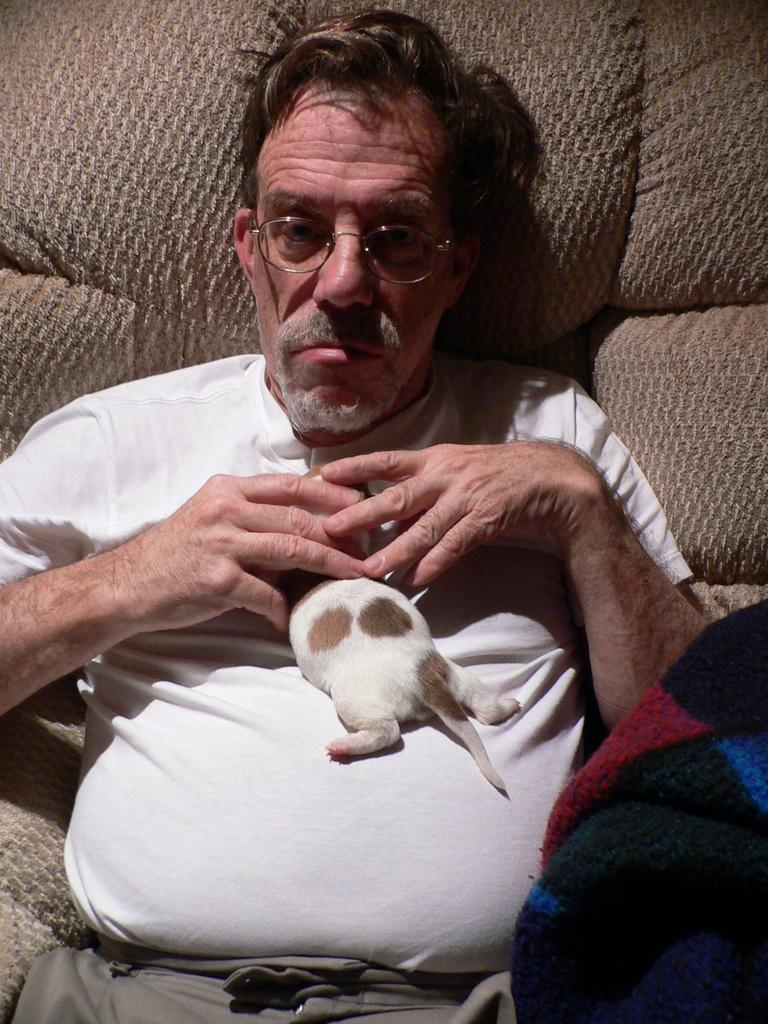What is the age of the person in the image? The person in the image is old. What is the person doing in the image? The person is sitting on a chair. What is the person holding in their hand? The person is holding an animal in their hand. What can be seen on the right side of the image? There is cloth visible on the right side of the image. What accessory is the person wearing? The person is wearing glasses. What type of paste is the person using to stick the cow to the wall in the image? There is no cow or paste present in the image. 